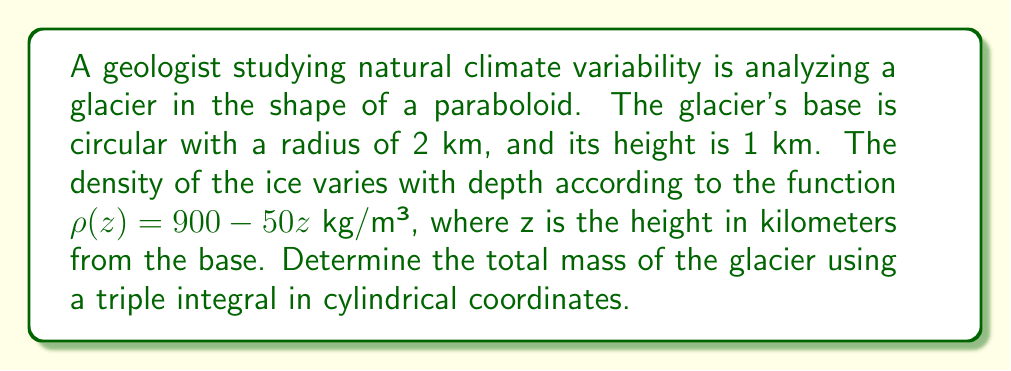Can you answer this question? To solve this problem, we need to set up and evaluate a triple integral in cylindrical coordinates. Let's approach this step-by-step:

1) First, we need to define the bounds of our integral:
   $r$: from 0 to 2 (radius in km)
   $\theta$: from 0 to $2\pi$ (full circle)
   $z$: from 0 to $1 - \frac{r^2}{4}$ (equation of the paraboloid)

2) The volume element in cylindrical coordinates is $r \, dr \, d\theta \, dz$.

3) The density function is given as $\rho(z) = 900 - 50z$ kg/m³.

4) The mass element is density times volume: $\rho(z) \cdot r \, dr \, d\theta \, dz$.

5) Now we can set up our triple integral:

   $$M = \int_0^{2\pi} \int_0^2 \int_0^{1-\frac{r^2}{4}} (900 - 50z) \cdot r \, dz \, dr \, d\theta$$

6) Let's solve the innermost integral first:

   $$\int_0^{1-\frac{r^2}{4}} (900 - 50z) \, dz = [900z - 25z^2]_0^{1-\frac{r^2}{4}}$$
   $$= 900(1-\frac{r^2}{4}) - 25(1-\frac{r^2}{4})^2 - 0$$
   $$= 900 - 225r^2 + \frac{25r^4}{16}$$

7) Now our integral becomes:

   $$M = \int_0^{2\pi} \int_0^2 (900 - 225r^2 + \frac{25r^4}{16}) \cdot r \, dr \, d\theta$$

8) Integrate with respect to r:

   $$\int_0^2 (900r - 75r^3 + \frac{5r^5}{16}) \, dr = [450r^2 - \frac{75r^4}{4} + \frac{5r^6}{96}]_0^2$$
   $$= 1800 - 300 + \frac{20}{3} - 0 = 1520 \frac{2}{3}$$

9) Finally, integrate with respect to $\theta$:

   $$M = \int_0^{2\pi} 1520 \frac{2}{3} \, d\theta = 1520 \frac{2}{3} \cdot 2\pi = 3041 \frac{1}{3}\pi$$

10) Convert units: The result is in kg·km², but we want it in kg. Multiply by $10^6$ to convert km² to m².

    $$M = 3041 \frac{1}{3}\pi \cdot 10^6 \text{ kg}$$
Answer: The total mass of the glacier is approximately $9.55 \times 10^9$ kg. 